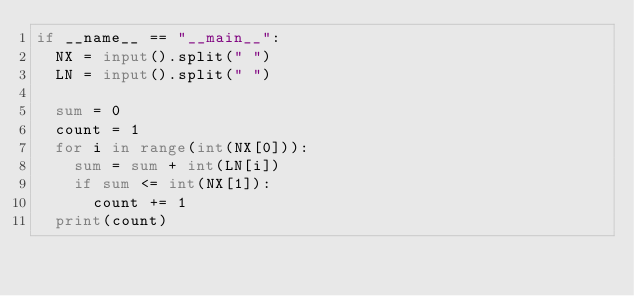Convert code to text. <code><loc_0><loc_0><loc_500><loc_500><_Python_>if __name__ == "__main__":
  NX = input().split(" ")
  LN = input().split(" ")
  
  sum = 0
  count = 1
  for i in range(int(NX[0])):
    sum = sum + int(LN[i])
    if sum <= int(NX[1]):
      count += 1
  print(count)</code> 